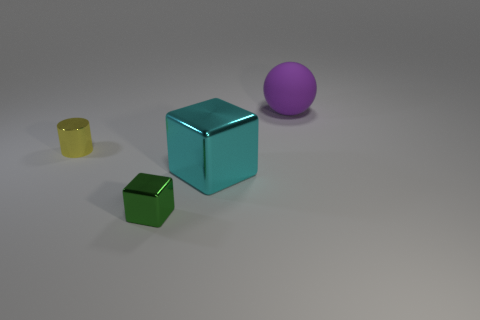How big is the green cube that is in front of the large object that is in front of the big purple thing?
Offer a terse response. Small. What number of other things are the same size as the cyan object?
Offer a very short reply. 1. There is a small green shiny block; what number of blocks are on the right side of it?
Offer a terse response. 1. The green object has what size?
Your response must be concise. Small. Is the material of the large thing in front of the large rubber object the same as the sphere behind the yellow thing?
Provide a succinct answer. No. There is another metal object that is the same size as the purple object; what is its color?
Provide a short and direct response. Cyan. Is there a yellow cylinder that has the same material as the tiny green object?
Offer a terse response. Yes. Are there fewer shiny objects that are in front of the large cyan shiny cube than small blue metal cylinders?
Ensure brevity in your answer.  No. There is a metal cube that is on the right side of the green object; is its size the same as the small cylinder?
Offer a terse response. No. What number of cyan metallic objects have the same shape as the green thing?
Offer a terse response. 1. 